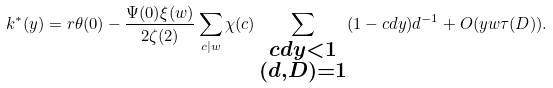Convert formula to latex. <formula><loc_0><loc_0><loc_500><loc_500>k ^ { * } ( y ) = r \theta ( 0 ) - \frac { \Psi ( 0 ) \xi ( w ) } { 2 \zeta ( 2 ) } \sum _ { c | w } \chi ( c ) \sum _ { \substack { c d y < 1 \\ ( d , D ) = 1 } } ( 1 - c d y ) d ^ { - 1 } + O ( y w \tau ( D ) ) .</formula> 